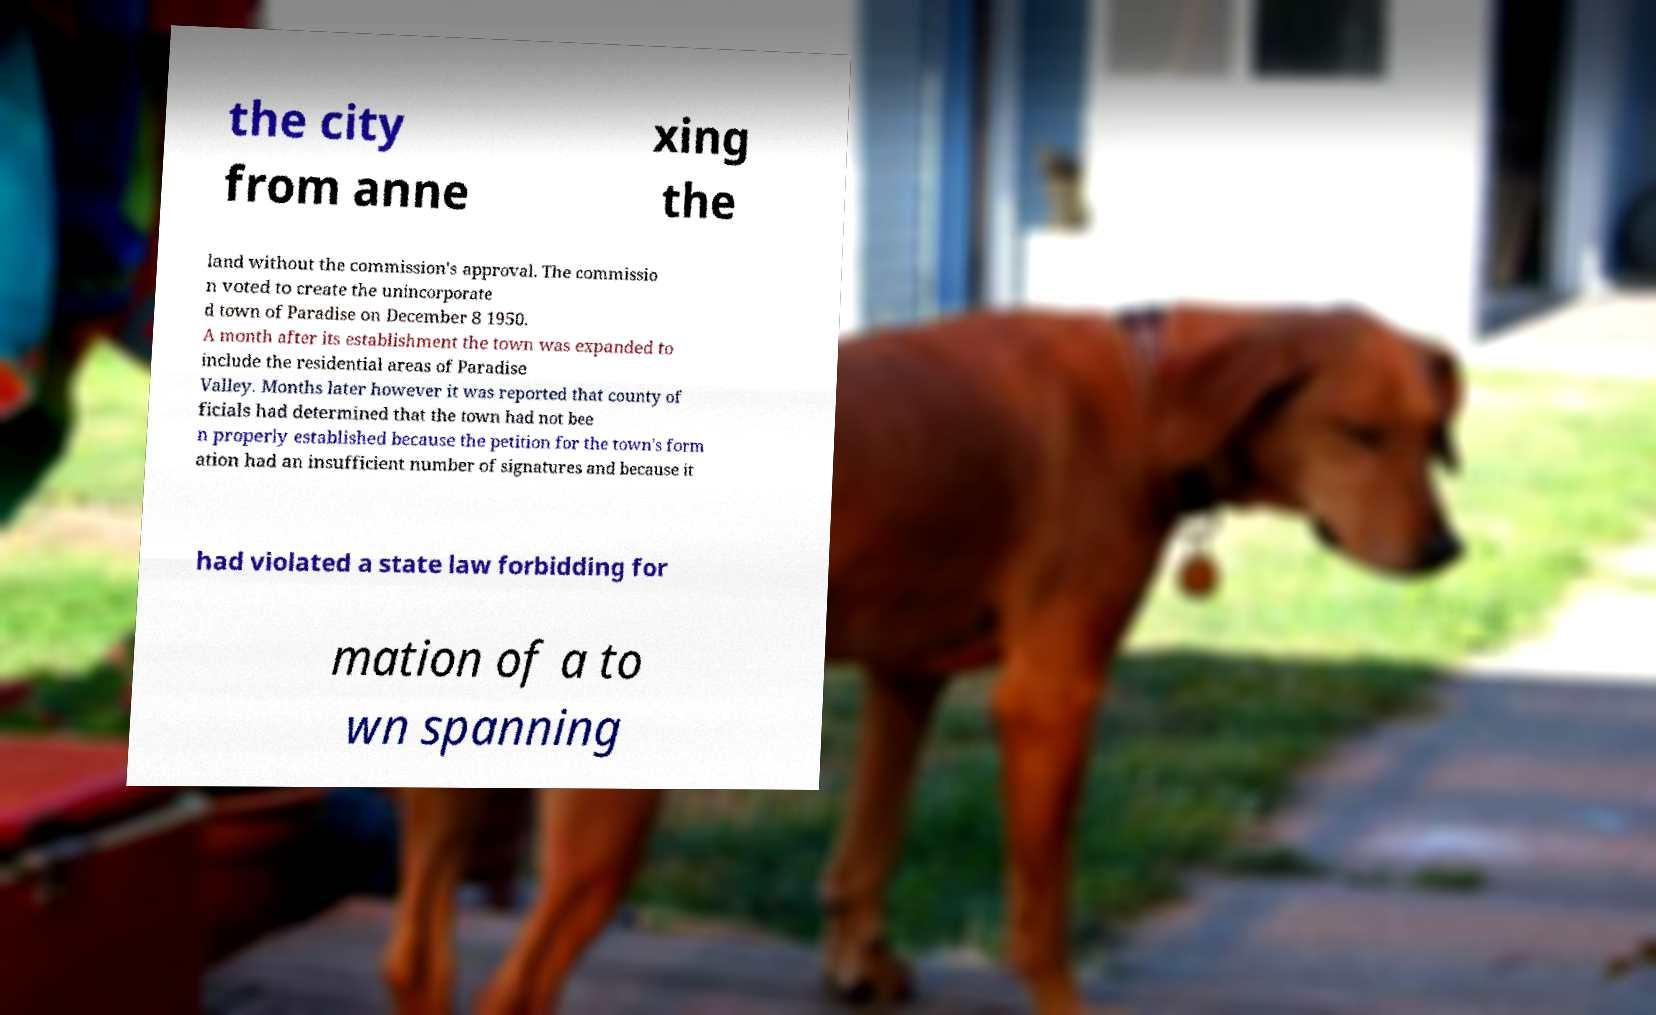What messages or text are displayed in this image? I need them in a readable, typed format. the city from anne xing the land without the commission's approval. The commissio n voted to create the unincorporate d town of Paradise on December 8 1950. A month after its establishment the town was expanded to include the residential areas of Paradise Valley. Months later however it was reported that county of ficials had determined that the town had not bee n properly established because the petition for the town's form ation had an insufficient number of signatures and because it had violated a state law forbidding for mation of a to wn spanning 